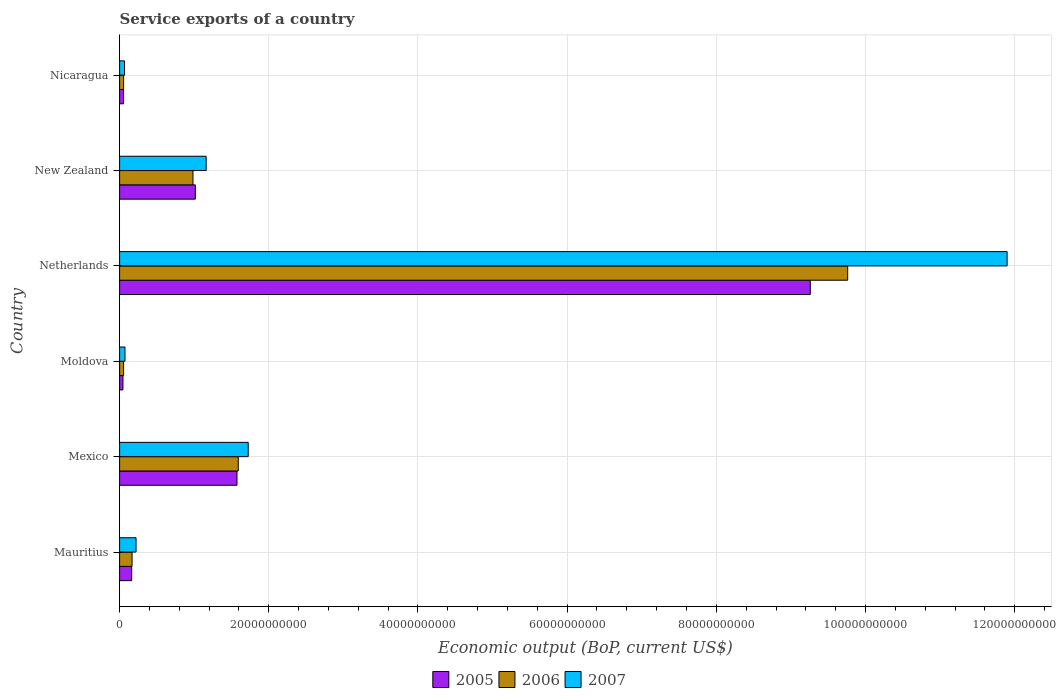How many groups of bars are there?
Offer a terse response. 6. Are the number of bars per tick equal to the number of legend labels?
Your answer should be very brief. Yes. Are the number of bars on each tick of the Y-axis equal?
Provide a short and direct response. Yes. What is the label of the 2nd group of bars from the top?
Make the answer very short. New Zealand. What is the service exports in 2005 in Mexico?
Offer a very short reply. 1.57e+1. Across all countries, what is the maximum service exports in 2007?
Make the answer very short. 1.19e+11. Across all countries, what is the minimum service exports in 2007?
Offer a very short reply. 6.66e+08. In which country was the service exports in 2005 maximum?
Provide a short and direct response. Netherlands. In which country was the service exports in 2005 minimum?
Keep it short and to the point. Moldova. What is the total service exports in 2006 in the graph?
Offer a terse response. 1.26e+11. What is the difference between the service exports in 2005 in Mauritius and that in Moldova?
Your response must be concise. 1.17e+09. What is the difference between the service exports in 2005 in Nicaragua and the service exports in 2007 in Mauritius?
Make the answer very short. -1.67e+09. What is the average service exports in 2007 per country?
Your answer should be compact. 2.52e+1. What is the difference between the service exports in 2006 and service exports in 2005 in Netherlands?
Your answer should be compact. 5.02e+09. In how many countries, is the service exports in 2005 greater than 60000000000 US$?
Offer a terse response. 1. What is the ratio of the service exports in 2007 in Netherlands to that in New Zealand?
Your answer should be very brief. 10.25. Is the service exports in 2007 in Mexico less than that in Moldova?
Your answer should be very brief. No. What is the difference between the highest and the second highest service exports in 2006?
Make the answer very short. 8.17e+1. What is the difference between the highest and the lowest service exports in 2005?
Make the answer very short. 9.21e+1. In how many countries, is the service exports in 2005 greater than the average service exports in 2005 taken over all countries?
Your answer should be compact. 1. Is the sum of the service exports in 2006 in Mexico and Moldova greater than the maximum service exports in 2005 across all countries?
Ensure brevity in your answer.  No. What does the 1st bar from the bottom in Nicaragua represents?
Ensure brevity in your answer.  2005. How many bars are there?
Your response must be concise. 18. Are all the bars in the graph horizontal?
Offer a terse response. Yes. How many countries are there in the graph?
Your response must be concise. 6. Are the values on the major ticks of X-axis written in scientific E-notation?
Give a very brief answer. No. Does the graph contain any zero values?
Make the answer very short. No. Where does the legend appear in the graph?
Give a very brief answer. Bottom center. How are the legend labels stacked?
Your answer should be very brief. Horizontal. What is the title of the graph?
Give a very brief answer. Service exports of a country. Does "1991" appear as one of the legend labels in the graph?
Make the answer very short. No. What is the label or title of the X-axis?
Offer a very short reply. Economic output (BoP, current US$). What is the Economic output (BoP, current US$) in 2005 in Mauritius?
Ensure brevity in your answer.  1.62e+09. What is the Economic output (BoP, current US$) in 2006 in Mauritius?
Make the answer very short. 1.67e+09. What is the Economic output (BoP, current US$) of 2007 in Mauritius?
Make the answer very short. 2.21e+09. What is the Economic output (BoP, current US$) in 2005 in Mexico?
Your answer should be compact. 1.57e+1. What is the Economic output (BoP, current US$) of 2006 in Mexico?
Your answer should be compact. 1.59e+1. What is the Economic output (BoP, current US$) of 2007 in Mexico?
Offer a very short reply. 1.72e+1. What is the Economic output (BoP, current US$) in 2005 in Moldova?
Ensure brevity in your answer.  4.46e+08. What is the Economic output (BoP, current US$) in 2006 in Moldova?
Ensure brevity in your answer.  5.35e+08. What is the Economic output (BoP, current US$) in 2007 in Moldova?
Give a very brief answer. 7.19e+08. What is the Economic output (BoP, current US$) of 2005 in Netherlands?
Make the answer very short. 9.26e+1. What is the Economic output (BoP, current US$) in 2006 in Netherlands?
Provide a short and direct response. 9.76e+1. What is the Economic output (BoP, current US$) in 2007 in Netherlands?
Offer a terse response. 1.19e+11. What is the Economic output (BoP, current US$) of 2005 in New Zealand?
Keep it short and to the point. 1.02e+1. What is the Economic output (BoP, current US$) of 2006 in New Zealand?
Your response must be concise. 9.84e+09. What is the Economic output (BoP, current US$) in 2007 in New Zealand?
Your answer should be very brief. 1.16e+1. What is the Economic output (BoP, current US$) of 2005 in Nicaragua?
Provide a succinct answer. 5.31e+08. What is the Economic output (BoP, current US$) of 2006 in Nicaragua?
Your response must be concise. 5.39e+08. What is the Economic output (BoP, current US$) of 2007 in Nicaragua?
Your response must be concise. 6.66e+08. Across all countries, what is the maximum Economic output (BoP, current US$) in 2005?
Offer a very short reply. 9.26e+1. Across all countries, what is the maximum Economic output (BoP, current US$) of 2006?
Offer a very short reply. 9.76e+1. Across all countries, what is the maximum Economic output (BoP, current US$) of 2007?
Your response must be concise. 1.19e+11. Across all countries, what is the minimum Economic output (BoP, current US$) in 2005?
Your answer should be very brief. 4.46e+08. Across all countries, what is the minimum Economic output (BoP, current US$) in 2006?
Your answer should be very brief. 5.35e+08. Across all countries, what is the minimum Economic output (BoP, current US$) of 2007?
Give a very brief answer. 6.66e+08. What is the total Economic output (BoP, current US$) of 2005 in the graph?
Offer a very short reply. 1.21e+11. What is the total Economic output (BoP, current US$) of 2006 in the graph?
Provide a short and direct response. 1.26e+11. What is the total Economic output (BoP, current US$) of 2007 in the graph?
Your response must be concise. 1.51e+11. What is the difference between the Economic output (BoP, current US$) of 2005 in Mauritius and that in Mexico?
Keep it short and to the point. -1.41e+1. What is the difference between the Economic output (BoP, current US$) in 2006 in Mauritius and that in Mexico?
Keep it short and to the point. -1.42e+1. What is the difference between the Economic output (BoP, current US$) of 2007 in Mauritius and that in Mexico?
Make the answer very short. -1.50e+1. What is the difference between the Economic output (BoP, current US$) of 2005 in Mauritius and that in Moldova?
Your response must be concise. 1.17e+09. What is the difference between the Economic output (BoP, current US$) of 2006 in Mauritius and that in Moldova?
Your response must be concise. 1.14e+09. What is the difference between the Economic output (BoP, current US$) of 2007 in Mauritius and that in Moldova?
Ensure brevity in your answer.  1.49e+09. What is the difference between the Economic output (BoP, current US$) in 2005 in Mauritius and that in Netherlands?
Keep it short and to the point. -9.10e+1. What is the difference between the Economic output (BoP, current US$) of 2006 in Mauritius and that in Netherlands?
Ensure brevity in your answer.  -9.59e+1. What is the difference between the Economic output (BoP, current US$) in 2007 in Mauritius and that in Netherlands?
Give a very brief answer. -1.17e+11. What is the difference between the Economic output (BoP, current US$) in 2005 in Mauritius and that in New Zealand?
Keep it short and to the point. -8.53e+09. What is the difference between the Economic output (BoP, current US$) of 2006 in Mauritius and that in New Zealand?
Make the answer very short. -8.17e+09. What is the difference between the Economic output (BoP, current US$) in 2007 in Mauritius and that in New Zealand?
Make the answer very short. -9.40e+09. What is the difference between the Economic output (BoP, current US$) in 2005 in Mauritius and that in Nicaragua?
Ensure brevity in your answer.  1.09e+09. What is the difference between the Economic output (BoP, current US$) in 2006 in Mauritius and that in Nicaragua?
Give a very brief answer. 1.13e+09. What is the difference between the Economic output (BoP, current US$) in 2007 in Mauritius and that in Nicaragua?
Provide a succinct answer. 1.54e+09. What is the difference between the Economic output (BoP, current US$) of 2005 in Mexico and that in Moldova?
Give a very brief answer. 1.53e+1. What is the difference between the Economic output (BoP, current US$) of 2006 in Mexico and that in Moldova?
Offer a very short reply. 1.54e+1. What is the difference between the Economic output (BoP, current US$) in 2007 in Mexico and that in Moldova?
Offer a terse response. 1.65e+1. What is the difference between the Economic output (BoP, current US$) of 2005 in Mexico and that in Netherlands?
Give a very brief answer. -7.69e+1. What is the difference between the Economic output (BoP, current US$) in 2006 in Mexico and that in Netherlands?
Offer a terse response. -8.17e+1. What is the difference between the Economic output (BoP, current US$) in 2007 in Mexico and that in Netherlands?
Provide a short and direct response. -1.02e+11. What is the difference between the Economic output (BoP, current US$) of 2005 in Mexico and that in New Zealand?
Your response must be concise. 5.58e+09. What is the difference between the Economic output (BoP, current US$) in 2006 in Mexico and that in New Zealand?
Ensure brevity in your answer.  6.07e+09. What is the difference between the Economic output (BoP, current US$) of 2007 in Mexico and that in New Zealand?
Keep it short and to the point. 5.64e+09. What is the difference between the Economic output (BoP, current US$) in 2005 in Mexico and that in Nicaragua?
Provide a succinct answer. 1.52e+1. What is the difference between the Economic output (BoP, current US$) in 2006 in Mexico and that in Nicaragua?
Ensure brevity in your answer.  1.54e+1. What is the difference between the Economic output (BoP, current US$) of 2007 in Mexico and that in Nicaragua?
Offer a very short reply. 1.66e+1. What is the difference between the Economic output (BoP, current US$) of 2005 in Moldova and that in Netherlands?
Keep it short and to the point. -9.21e+1. What is the difference between the Economic output (BoP, current US$) in 2006 in Moldova and that in Netherlands?
Your answer should be very brief. -9.71e+1. What is the difference between the Economic output (BoP, current US$) of 2007 in Moldova and that in Netherlands?
Ensure brevity in your answer.  -1.18e+11. What is the difference between the Economic output (BoP, current US$) in 2005 in Moldova and that in New Zealand?
Your answer should be very brief. -9.71e+09. What is the difference between the Economic output (BoP, current US$) in 2006 in Moldova and that in New Zealand?
Your response must be concise. -9.30e+09. What is the difference between the Economic output (BoP, current US$) in 2007 in Moldova and that in New Zealand?
Ensure brevity in your answer.  -1.09e+1. What is the difference between the Economic output (BoP, current US$) of 2005 in Moldova and that in Nicaragua?
Offer a terse response. -8.46e+07. What is the difference between the Economic output (BoP, current US$) of 2006 in Moldova and that in Nicaragua?
Your answer should be compact. -3.60e+06. What is the difference between the Economic output (BoP, current US$) in 2007 in Moldova and that in Nicaragua?
Your response must be concise. 5.38e+07. What is the difference between the Economic output (BoP, current US$) in 2005 in Netherlands and that in New Zealand?
Keep it short and to the point. 8.24e+1. What is the difference between the Economic output (BoP, current US$) in 2006 in Netherlands and that in New Zealand?
Offer a terse response. 8.78e+1. What is the difference between the Economic output (BoP, current US$) of 2007 in Netherlands and that in New Zealand?
Your answer should be very brief. 1.07e+11. What is the difference between the Economic output (BoP, current US$) of 2005 in Netherlands and that in Nicaragua?
Your answer should be very brief. 9.21e+1. What is the difference between the Economic output (BoP, current US$) in 2006 in Netherlands and that in Nicaragua?
Give a very brief answer. 9.71e+1. What is the difference between the Economic output (BoP, current US$) of 2007 in Netherlands and that in Nicaragua?
Your answer should be very brief. 1.18e+11. What is the difference between the Economic output (BoP, current US$) in 2005 in New Zealand and that in Nicaragua?
Offer a terse response. 9.62e+09. What is the difference between the Economic output (BoP, current US$) in 2006 in New Zealand and that in Nicaragua?
Your answer should be compact. 9.30e+09. What is the difference between the Economic output (BoP, current US$) in 2007 in New Zealand and that in Nicaragua?
Provide a succinct answer. 1.09e+1. What is the difference between the Economic output (BoP, current US$) of 2005 in Mauritius and the Economic output (BoP, current US$) of 2006 in Mexico?
Your response must be concise. -1.43e+1. What is the difference between the Economic output (BoP, current US$) of 2005 in Mauritius and the Economic output (BoP, current US$) of 2007 in Mexico?
Make the answer very short. -1.56e+1. What is the difference between the Economic output (BoP, current US$) in 2006 in Mauritius and the Economic output (BoP, current US$) in 2007 in Mexico?
Ensure brevity in your answer.  -1.56e+1. What is the difference between the Economic output (BoP, current US$) of 2005 in Mauritius and the Economic output (BoP, current US$) of 2006 in Moldova?
Your response must be concise. 1.08e+09. What is the difference between the Economic output (BoP, current US$) of 2005 in Mauritius and the Economic output (BoP, current US$) of 2007 in Moldova?
Give a very brief answer. 8.99e+08. What is the difference between the Economic output (BoP, current US$) in 2006 in Mauritius and the Economic output (BoP, current US$) in 2007 in Moldova?
Make the answer very short. 9.52e+08. What is the difference between the Economic output (BoP, current US$) in 2005 in Mauritius and the Economic output (BoP, current US$) in 2006 in Netherlands?
Your answer should be compact. -9.60e+1. What is the difference between the Economic output (BoP, current US$) in 2005 in Mauritius and the Economic output (BoP, current US$) in 2007 in Netherlands?
Ensure brevity in your answer.  -1.17e+11. What is the difference between the Economic output (BoP, current US$) in 2006 in Mauritius and the Economic output (BoP, current US$) in 2007 in Netherlands?
Provide a succinct answer. -1.17e+11. What is the difference between the Economic output (BoP, current US$) of 2005 in Mauritius and the Economic output (BoP, current US$) of 2006 in New Zealand?
Your answer should be very brief. -8.22e+09. What is the difference between the Economic output (BoP, current US$) in 2005 in Mauritius and the Economic output (BoP, current US$) in 2007 in New Zealand?
Make the answer very short. -9.99e+09. What is the difference between the Economic output (BoP, current US$) of 2006 in Mauritius and the Economic output (BoP, current US$) of 2007 in New Zealand?
Offer a terse response. -9.93e+09. What is the difference between the Economic output (BoP, current US$) in 2005 in Mauritius and the Economic output (BoP, current US$) in 2006 in Nicaragua?
Make the answer very short. 1.08e+09. What is the difference between the Economic output (BoP, current US$) in 2005 in Mauritius and the Economic output (BoP, current US$) in 2007 in Nicaragua?
Make the answer very short. 9.53e+08. What is the difference between the Economic output (BoP, current US$) of 2006 in Mauritius and the Economic output (BoP, current US$) of 2007 in Nicaragua?
Give a very brief answer. 1.01e+09. What is the difference between the Economic output (BoP, current US$) in 2005 in Mexico and the Economic output (BoP, current US$) in 2006 in Moldova?
Provide a short and direct response. 1.52e+1. What is the difference between the Economic output (BoP, current US$) in 2005 in Mexico and the Economic output (BoP, current US$) in 2007 in Moldova?
Keep it short and to the point. 1.50e+1. What is the difference between the Economic output (BoP, current US$) in 2006 in Mexico and the Economic output (BoP, current US$) in 2007 in Moldova?
Your answer should be very brief. 1.52e+1. What is the difference between the Economic output (BoP, current US$) in 2005 in Mexico and the Economic output (BoP, current US$) in 2006 in Netherlands?
Ensure brevity in your answer.  -8.19e+1. What is the difference between the Economic output (BoP, current US$) of 2005 in Mexico and the Economic output (BoP, current US$) of 2007 in Netherlands?
Your answer should be very brief. -1.03e+11. What is the difference between the Economic output (BoP, current US$) in 2006 in Mexico and the Economic output (BoP, current US$) in 2007 in Netherlands?
Keep it short and to the point. -1.03e+11. What is the difference between the Economic output (BoP, current US$) in 2005 in Mexico and the Economic output (BoP, current US$) in 2006 in New Zealand?
Give a very brief answer. 5.90e+09. What is the difference between the Economic output (BoP, current US$) in 2005 in Mexico and the Economic output (BoP, current US$) in 2007 in New Zealand?
Your answer should be very brief. 4.13e+09. What is the difference between the Economic output (BoP, current US$) in 2006 in Mexico and the Economic output (BoP, current US$) in 2007 in New Zealand?
Your answer should be very brief. 4.30e+09. What is the difference between the Economic output (BoP, current US$) in 2005 in Mexico and the Economic output (BoP, current US$) in 2006 in Nicaragua?
Provide a succinct answer. 1.52e+1. What is the difference between the Economic output (BoP, current US$) of 2005 in Mexico and the Economic output (BoP, current US$) of 2007 in Nicaragua?
Your answer should be very brief. 1.51e+1. What is the difference between the Economic output (BoP, current US$) in 2006 in Mexico and the Economic output (BoP, current US$) in 2007 in Nicaragua?
Offer a terse response. 1.52e+1. What is the difference between the Economic output (BoP, current US$) in 2005 in Moldova and the Economic output (BoP, current US$) in 2006 in Netherlands?
Give a very brief answer. -9.72e+1. What is the difference between the Economic output (BoP, current US$) of 2005 in Moldova and the Economic output (BoP, current US$) of 2007 in Netherlands?
Offer a very short reply. -1.19e+11. What is the difference between the Economic output (BoP, current US$) in 2006 in Moldova and the Economic output (BoP, current US$) in 2007 in Netherlands?
Your answer should be very brief. -1.18e+11. What is the difference between the Economic output (BoP, current US$) in 2005 in Moldova and the Economic output (BoP, current US$) in 2006 in New Zealand?
Provide a succinct answer. -9.39e+09. What is the difference between the Economic output (BoP, current US$) in 2005 in Moldova and the Economic output (BoP, current US$) in 2007 in New Zealand?
Make the answer very short. -1.12e+1. What is the difference between the Economic output (BoP, current US$) of 2006 in Moldova and the Economic output (BoP, current US$) of 2007 in New Zealand?
Ensure brevity in your answer.  -1.11e+1. What is the difference between the Economic output (BoP, current US$) of 2005 in Moldova and the Economic output (BoP, current US$) of 2006 in Nicaragua?
Your answer should be compact. -9.26e+07. What is the difference between the Economic output (BoP, current US$) in 2005 in Moldova and the Economic output (BoP, current US$) in 2007 in Nicaragua?
Offer a terse response. -2.19e+08. What is the difference between the Economic output (BoP, current US$) of 2006 in Moldova and the Economic output (BoP, current US$) of 2007 in Nicaragua?
Ensure brevity in your answer.  -1.30e+08. What is the difference between the Economic output (BoP, current US$) of 2005 in Netherlands and the Economic output (BoP, current US$) of 2006 in New Zealand?
Keep it short and to the point. 8.28e+1. What is the difference between the Economic output (BoP, current US$) in 2005 in Netherlands and the Economic output (BoP, current US$) in 2007 in New Zealand?
Keep it short and to the point. 8.10e+1. What is the difference between the Economic output (BoP, current US$) in 2006 in Netherlands and the Economic output (BoP, current US$) in 2007 in New Zealand?
Offer a very short reply. 8.60e+1. What is the difference between the Economic output (BoP, current US$) of 2005 in Netherlands and the Economic output (BoP, current US$) of 2006 in Nicaragua?
Give a very brief answer. 9.21e+1. What is the difference between the Economic output (BoP, current US$) in 2005 in Netherlands and the Economic output (BoP, current US$) in 2007 in Nicaragua?
Offer a terse response. 9.19e+1. What is the difference between the Economic output (BoP, current US$) in 2006 in Netherlands and the Economic output (BoP, current US$) in 2007 in Nicaragua?
Offer a terse response. 9.69e+1. What is the difference between the Economic output (BoP, current US$) of 2005 in New Zealand and the Economic output (BoP, current US$) of 2006 in Nicaragua?
Your response must be concise. 9.61e+09. What is the difference between the Economic output (BoP, current US$) in 2005 in New Zealand and the Economic output (BoP, current US$) in 2007 in Nicaragua?
Provide a short and direct response. 9.49e+09. What is the difference between the Economic output (BoP, current US$) of 2006 in New Zealand and the Economic output (BoP, current US$) of 2007 in Nicaragua?
Provide a succinct answer. 9.17e+09. What is the average Economic output (BoP, current US$) in 2005 per country?
Your response must be concise. 2.02e+1. What is the average Economic output (BoP, current US$) of 2006 per country?
Offer a very short reply. 2.10e+1. What is the average Economic output (BoP, current US$) in 2007 per country?
Ensure brevity in your answer.  2.52e+1. What is the difference between the Economic output (BoP, current US$) of 2005 and Economic output (BoP, current US$) of 2006 in Mauritius?
Make the answer very short. -5.32e+07. What is the difference between the Economic output (BoP, current US$) in 2005 and Economic output (BoP, current US$) in 2007 in Mauritius?
Provide a succinct answer. -5.87e+08. What is the difference between the Economic output (BoP, current US$) in 2006 and Economic output (BoP, current US$) in 2007 in Mauritius?
Your answer should be very brief. -5.34e+08. What is the difference between the Economic output (BoP, current US$) in 2005 and Economic output (BoP, current US$) in 2006 in Mexico?
Offer a terse response. -1.73e+08. What is the difference between the Economic output (BoP, current US$) in 2005 and Economic output (BoP, current US$) in 2007 in Mexico?
Make the answer very short. -1.51e+09. What is the difference between the Economic output (BoP, current US$) in 2006 and Economic output (BoP, current US$) in 2007 in Mexico?
Provide a short and direct response. -1.34e+09. What is the difference between the Economic output (BoP, current US$) in 2005 and Economic output (BoP, current US$) in 2006 in Moldova?
Offer a terse response. -8.90e+07. What is the difference between the Economic output (BoP, current US$) of 2005 and Economic output (BoP, current US$) of 2007 in Moldova?
Your response must be concise. -2.73e+08. What is the difference between the Economic output (BoP, current US$) in 2006 and Economic output (BoP, current US$) in 2007 in Moldova?
Your answer should be very brief. -1.84e+08. What is the difference between the Economic output (BoP, current US$) of 2005 and Economic output (BoP, current US$) of 2006 in Netherlands?
Ensure brevity in your answer.  -5.02e+09. What is the difference between the Economic output (BoP, current US$) in 2005 and Economic output (BoP, current US$) in 2007 in Netherlands?
Your response must be concise. -2.64e+1. What is the difference between the Economic output (BoP, current US$) of 2006 and Economic output (BoP, current US$) of 2007 in Netherlands?
Offer a very short reply. -2.14e+1. What is the difference between the Economic output (BoP, current US$) of 2005 and Economic output (BoP, current US$) of 2006 in New Zealand?
Provide a short and direct response. 3.15e+08. What is the difference between the Economic output (BoP, current US$) in 2005 and Economic output (BoP, current US$) in 2007 in New Zealand?
Your response must be concise. -1.45e+09. What is the difference between the Economic output (BoP, current US$) of 2006 and Economic output (BoP, current US$) of 2007 in New Zealand?
Provide a succinct answer. -1.77e+09. What is the difference between the Economic output (BoP, current US$) in 2005 and Economic output (BoP, current US$) in 2006 in Nicaragua?
Provide a succinct answer. -8.00e+06. What is the difference between the Economic output (BoP, current US$) of 2005 and Economic output (BoP, current US$) of 2007 in Nicaragua?
Provide a succinct answer. -1.35e+08. What is the difference between the Economic output (BoP, current US$) in 2006 and Economic output (BoP, current US$) in 2007 in Nicaragua?
Your response must be concise. -1.27e+08. What is the ratio of the Economic output (BoP, current US$) in 2005 in Mauritius to that in Mexico?
Keep it short and to the point. 0.1. What is the ratio of the Economic output (BoP, current US$) of 2006 in Mauritius to that in Mexico?
Ensure brevity in your answer.  0.11. What is the ratio of the Economic output (BoP, current US$) of 2007 in Mauritius to that in Mexico?
Your response must be concise. 0.13. What is the ratio of the Economic output (BoP, current US$) of 2005 in Mauritius to that in Moldova?
Your answer should be very brief. 3.63. What is the ratio of the Economic output (BoP, current US$) in 2006 in Mauritius to that in Moldova?
Give a very brief answer. 3.12. What is the ratio of the Economic output (BoP, current US$) of 2007 in Mauritius to that in Moldova?
Provide a short and direct response. 3.07. What is the ratio of the Economic output (BoP, current US$) of 2005 in Mauritius to that in Netherlands?
Ensure brevity in your answer.  0.02. What is the ratio of the Economic output (BoP, current US$) of 2006 in Mauritius to that in Netherlands?
Keep it short and to the point. 0.02. What is the ratio of the Economic output (BoP, current US$) in 2007 in Mauritius to that in Netherlands?
Keep it short and to the point. 0.02. What is the ratio of the Economic output (BoP, current US$) of 2005 in Mauritius to that in New Zealand?
Your answer should be compact. 0.16. What is the ratio of the Economic output (BoP, current US$) of 2006 in Mauritius to that in New Zealand?
Your answer should be compact. 0.17. What is the ratio of the Economic output (BoP, current US$) of 2007 in Mauritius to that in New Zealand?
Your response must be concise. 0.19. What is the ratio of the Economic output (BoP, current US$) of 2005 in Mauritius to that in Nicaragua?
Keep it short and to the point. 3.05. What is the ratio of the Economic output (BoP, current US$) in 2006 in Mauritius to that in Nicaragua?
Your answer should be compact. 3.1. What is the ratio of the Economic output (BoP, current US$) of 2007 in Mauritius to that in Nicaragua?
Your response must be concise. 3.31. What is the ratio of the Economic output (BoP, current US$) of 2005 in Mexico to that in Moldova?
Make the answer very short. 35.27. What is the ratio of the Economic output (BoP, current US$) in 2006 in Mexico to that in Moldova?
Make the answer very short. 29.73. What is the ratio of the Economic output (BoP, current US$) in 2007 in Mexico to that in Moldova?
Make the answer very short. 23.97. What is the ratio of the Economic output (BoP, current US$) in 2005 in Mexico to that in Netherlands?
Keep it short and to the point. 0.17. What is the ratio of the Economic output (BoP, current US$) of 2006 in Mexico to that in Netherlands?
Offer a very short reply. 0.16. What is the ratio of the Economic output (BoP, current US$) of 2007 in Mexico to that in Netherlands?
Make the answer very short. 0.14. What is the ratio of the Economic output (BoP, current US$) in 2005 in Mexico to that in New Zealand?
Give a very brief answer. 1.55. What is the ratio of the Economic output (BoP, current US$) in 2006 in Mexico to that in New Zealand?
Your response must be concise. 1.62. What is the ratio of the Economic output (BoP, current US$) in 2007 in Mexico to that in New Zealand?
Your answer should be very brief. 1.49. What is the ratio of the Economic output (BoP, current US$) of 2005 in Mexico to that in Nicaragua?
Your response must be concise. 29.65. What is the ratio of the Economic output (BoP, current US$) of 2006 in Mexico to that in Nicaragua?
Offer a terse response. 29.53. What is the ratio of the Economic output (BoP, current US$) in 2007 in Mexico to that in Nicaragua?
Offer a terse response. 25.91. What is the ratio of the Economic output (BoP, current US$) of 2005 in Moldova to that in Netherlands?
Offer a very short reply. 0. What is the ratio of the Economic output (BoP, current US$) of 2006 in Moldova to that in Netherlands?
Your response must be concise. 0.01. What is the ratio of the Economic output (BoP, current US$) in 2007 in Moldova to that in Netherlands?
Give a very brief answer. 0.01. What is the ratio of the Economic output (BoP, current US$) of 2005 in Moldova to that in New Zealand?
Offer a terse response. 0.04. What is the ratio of the Economic output (BoP, current US$) in 2006 in Moldova to that in New Zealand?
Provide a succinct answer. 0.05. What is the ratio of the Economic output (BoP, current US$) of 2007 in Moldova to that in New Zealand?
Give a very brief answer. 0.06. What is the ratio of the Economic output (BoP, current US$) of 2005 in Moldova to that in Nicaragua?
Give a very brief answer. 0.84. What is the ratio of the Economic output (BoP, current US$) of 2007 in Moldova to that in Nicaragua?
Make the answer very short. 1.08. What is the ratio of the Economic output (BoP, current US$) of 2005 in Netherlands to that in New Zealand?
Keep it short and to the point. 9.12. What is the ratio of the Economic output (BoP, current US$) in 2006 in Netherlands to that in New Zealand?
Make the answer very short. 9.92. What is the ratio of the Economic output (BoP, current US$) in 2007 in Netherlands to that in New Zealand?
Your answer should be compact. 10.25. What is the ratio of the Economic output (BoP, current US$) in 2005 in Netherlands to that in Nicaragua?
Your answer should be very brief. 174.48. What is the ratio of the Economic output (BoP, current US$) in 2006 in Netherlands to that in Nicaragua?
Your response must be concise. 181.2. What is the ratio of the Economic output (BoP, current US$) of 2007 in Netherlands to that in Nicaragua?
Your answer should be very brief. 178.76. What is the ratio of the Economic output (BoP, current US$) in 2005 in New Zealand to that in Nicaragua?
Your answer should be very brief. 19.13. What is the ratio of the Economic output (BoP, current US$) of 2006 in New Zealand to that in Nicaragua?
Offer a very short reply. 18.26. What is the ratio of the Economic output (BoP, current US$) of 2007 in New Zealand to that in Nicaragua?
Provide a succinct answer. 17.43. What is the difference between the highest and the second highest Economic output (BoP, current US$) in 2005?
Make the answer very short. 7.69e+1. What is the difference between the highest and the second highest Economic output (BoP, current US$) of 2006?
Offer a very short reply. 8.17e+1. What is the difference between the highest and the second highest Economic output (BoP, current US$) of 2007?
Your response must be concise. 1.02e+11. What is the difference between the highest and the lowest Economic output (BoP, current US$) in 2005?
Give a very brief answer. 9.21e+1. What is the difference between the highest and the lowest Economic output (BoP, current US$) in 2006?
Your response must be concise. 9.71e+1. What is the difference between the highest and the lowest Economic output (BoP, current US$) in 2007?
Your response must be concise. 1.18e+11. 